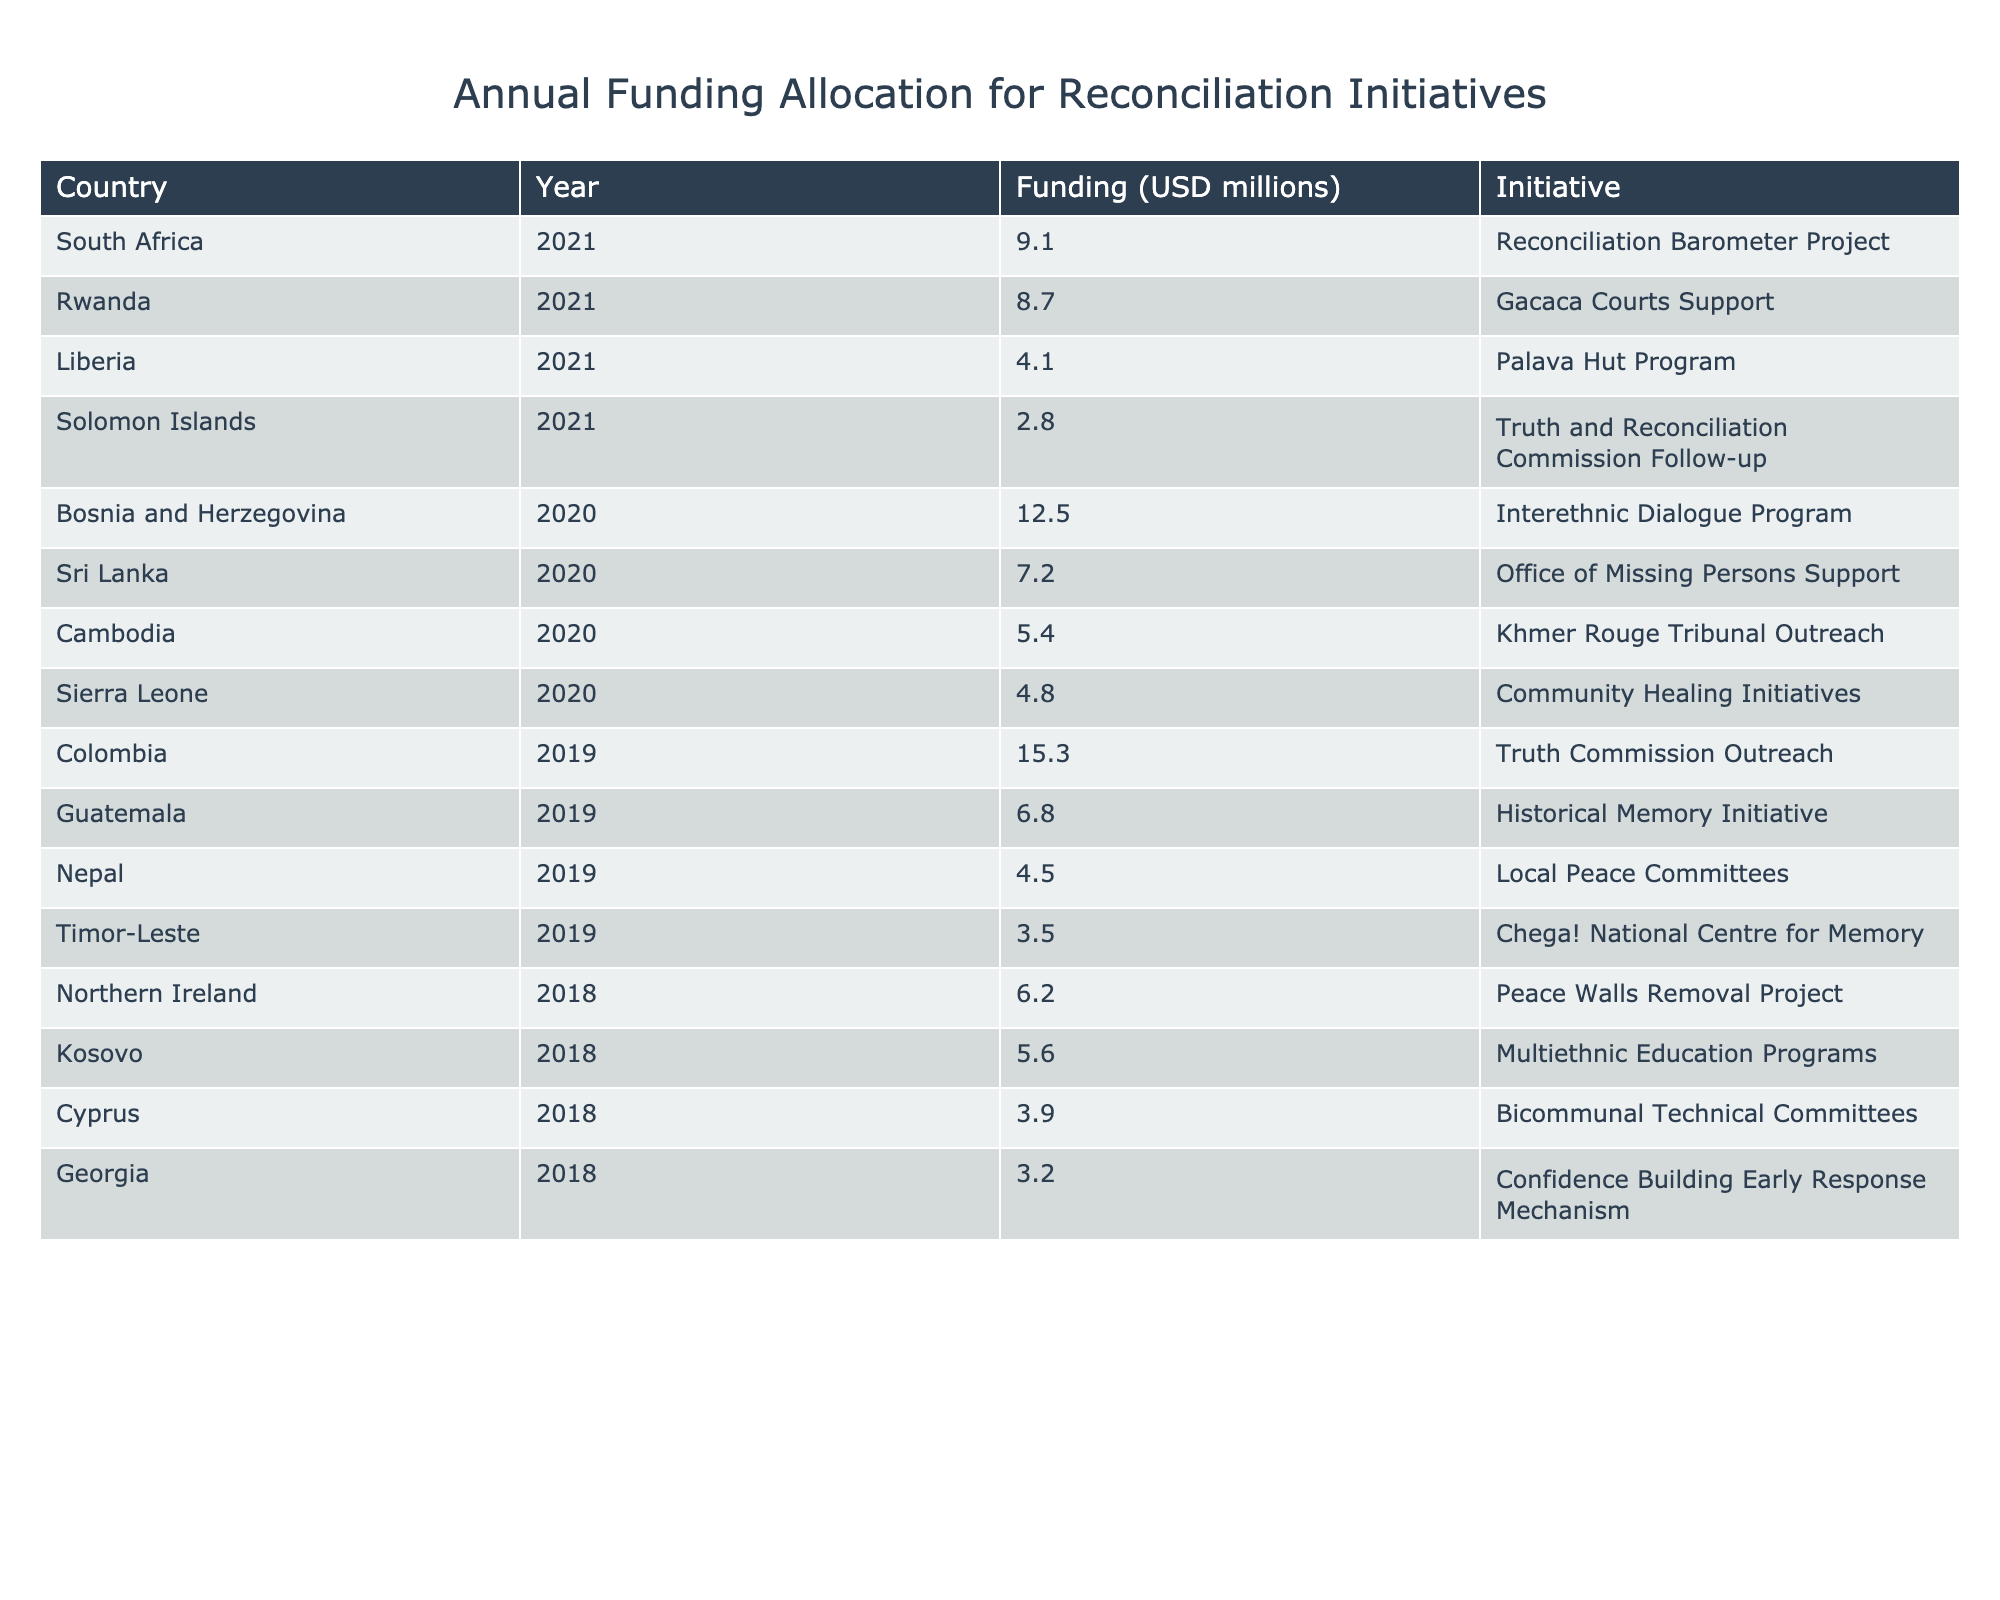What is the total funding allocated for reconciliation initiatives in 2020? To find the total for 2020, I look for entries in the Year column for 2020. The funding amounts are: 12.5 (Bosnia and Herzegovina), 4.8 (Sierra Leone), and 7.2 (Sri Lanka). Adding these gives: 12.5 + 4.8 + 7.2 = 24.5 million USD.
Answer: 24.5 million USD Which country received the highest funding for reconciliation initiatives in 2019? In 2019, the funding amounts are 15.3 (Colombia), 6.8 (Guatemala), and 4.5 (Nepal). The highest amount is clearly from Colombia with 15.3 million USD.
Answer: Colombia Is there a reconciliation initiative in Kosovo that received funding? Yes, in the table, Kosovo is listed with its initiative, which is the Multiethnic Education Programs with a funding of 5.6 million USD.
Answer: Yes How much funding was allocated to initiatives in South Africa and Rwanda combined? For South Africa, the funding is 9.1 million USD, and for Rwanda, it is 8.7 million USD. Adding these amounts together gives: 9.1 + 8.7 = 17.8 million USD.
Answer: 17.8 million USD Which year saw the least funding for reconciliation initiatives and what was the amount? The years listed are 2018, 2019, 2020, and 2021. Checking the funding amounts, the least is from the Solomon Islands in 2021 with 2.8 million USD.
Answer: 2021 with 2.8 million USD What percentage of the total funding in 2020 was allocated to Bosnia and Herzegovina? The total funding allocated in 2020 is 24.5 million USD as found previously, and Bosnia and Herzegovina received 12.5 million USD. The percentage calculation is (12.5 / 24.5) * 100 = 51.02%.
Answer: 51.02% Which country had a reconciliation initiative related to the Khmer Rouge Tribunal, and what was the funding amount? Cambodia's initiative is related to the Khmer Rouge Tribunal Outreach with a funding amount of 5.4 million USD.
Answer: Cambodia, 5.4 million USD How many initiatives in total received funding in 2018? The initiatives in 2018 listed are: Peace Walls Removal Project (Northern Ireland), Multiethnic Education Programs (Kosovo), and Confidence Building Early Response Mechanism (Georgia). This gives a total of 3 initiatives.
Answer: 3 initiatives Which two countries received the least funding for their reconciliation initiatives in 2021? In 2021, the funding amounts are: 9.1 (South Africa), 8.7 (Rwanda), 4.1 (Liberia), and 2.8 (Solomon Islands). The two least are Liberia with 4.1 million USD and Solomon Islands with 2.8 million USD.
Answer: Liberia and Solomon Islands If I were to rank the countries based on their funding in 2019 from highest to lowest, what would be the top two? The funding for 2019 from highest to lowest is: Colombia (15.3 million USD), Guatemala (6.8 million USD). Thus, the top two are Colombia and Guatemala.
Answer: Colombia, Guatemala What is the average funding for reconciliation initiatives across all countries listed in 2021? The total funding for 2021 includes: 8.7 (Rwanda), 9.1 (South Africa), 4.1 (Liberia), and 2.8 (Solomon Islands), giving a total of 24.7 million USD across 4 countries. The average funding is 24.7 / 4 = 6.175 million USD.
Answer: 6.175 million USD 